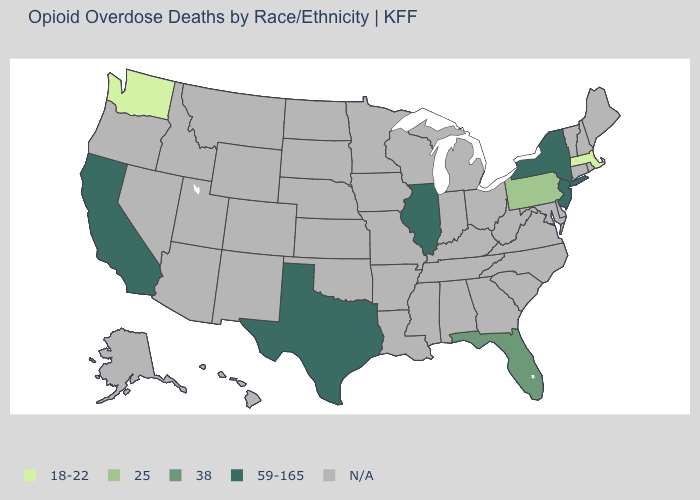What is the highest value in states that border Rhode Island?
Keep it brief. 18-22. What is the value of Delaware?
Quick response, please. N/A. What is the value of Texas?
Keep it brief. 59-165. What is the value of Arizona?
Write a very short answer. N/A. Which states have the lowest value in the USA?
Write a very short answer. Massachusetts, Washington. Name the states that have a value in the range 25?
Write a very short answer. Pennsylvania. What is the value of Mississippi?
Short answer required. N/A. Name the states that have a value in the range 38?
Concise answer only. Florida. 